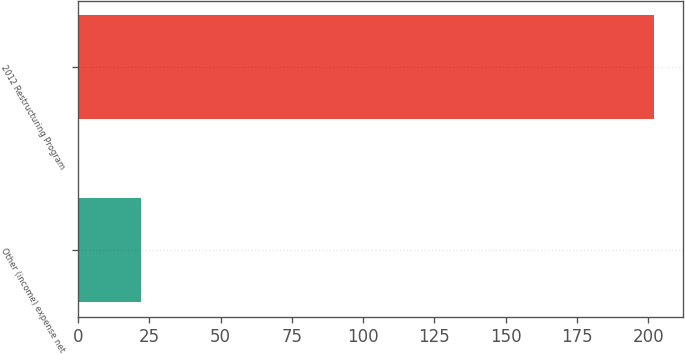Convert chart to OTSL. <chart><loc_0><loc_0><loc_500><loc_500><bar_chart><fcel>Other (income) expense net<fcel>2012 Restructuring Program<nl><fcel>22<fcel>202<nl></chart> 